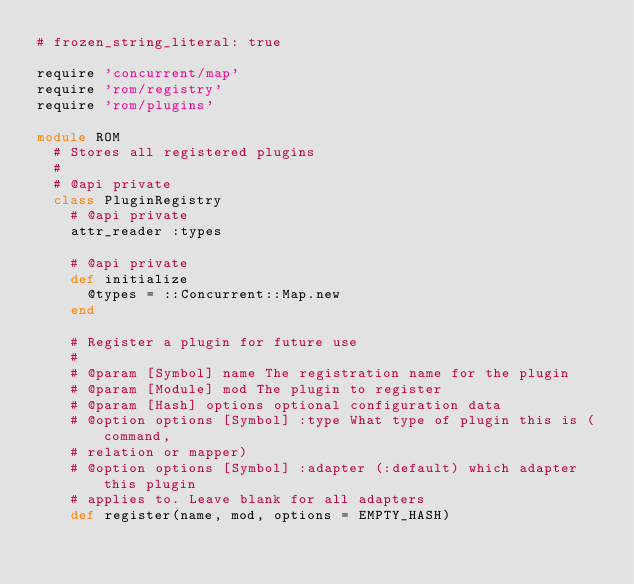<code> <loc_0><loc_0><loc_500><loc_500><_Ruby_># frozen_string_literal: true

require 'concurrent/map'
require 'rom/registry'
require 'rom/plugins'

module ROM
  # Stores all registered plugins
  #
  # @api private
  class PluginRegistry
    # @api private
    attr_reader :types

    # @api private
    def initialize
      @types = ::Concurrent::Map.new
    end

    # Register a plugin for future use
    #
    # @param [Symbol] name The registration name for the plugin
    # @param [Module] mod The plugin to register
    # @param [Hash] options optional configuration data
    # @option options [Symbol] :type What type of plugin this is (command,
    # relation or mapper)
    # @option options [Symbol] :adapter (:default) which adapter this plugin
    # applies to. Leave blank for all adapters
    def register(name, mod, options = EMPTY_HASH)</code> 